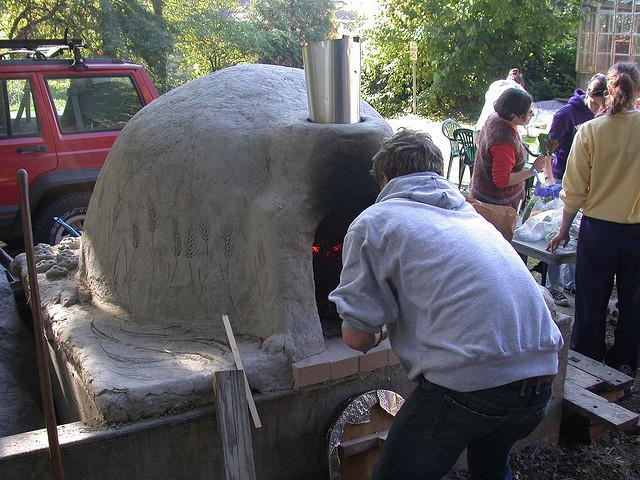In what location was this oven built?

Choices:
A) here
B) mexican factory
C) mall
D) farm here 